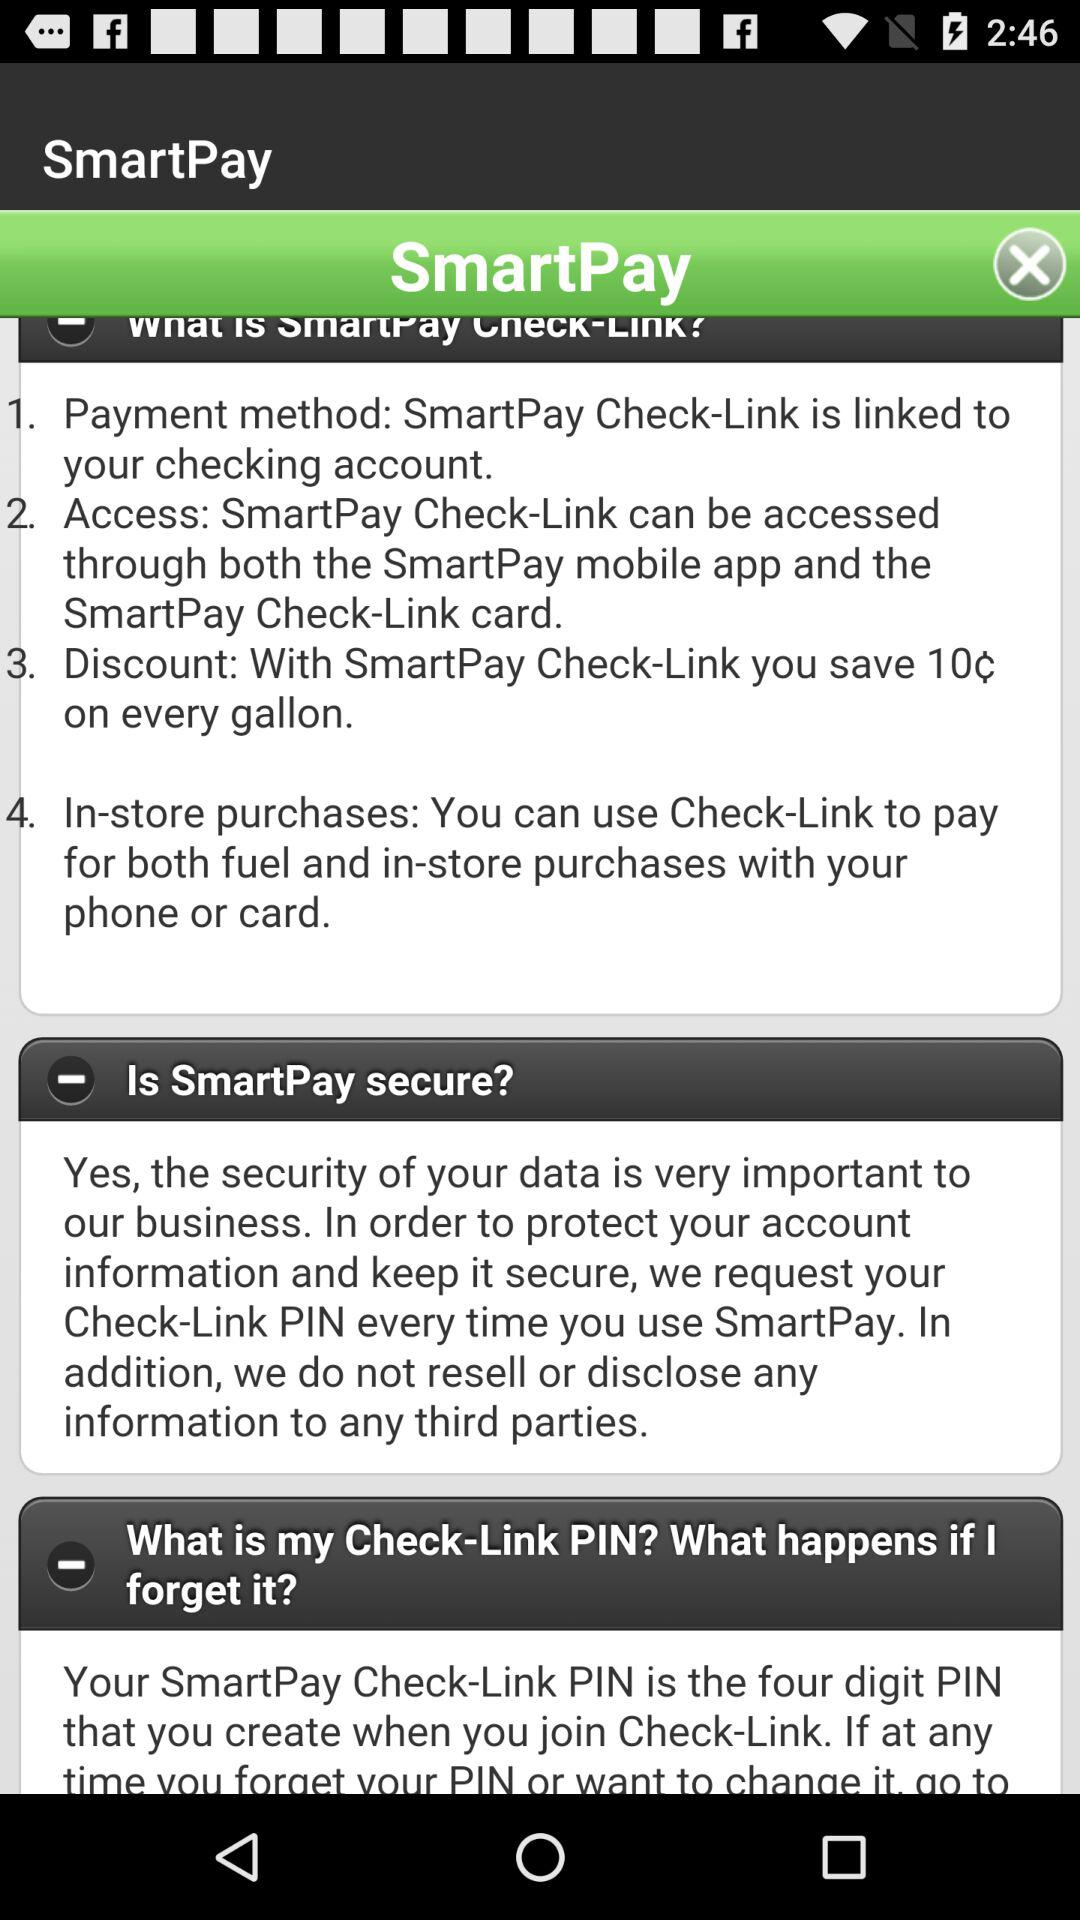What is the payment method? The payment method is "SmartPay Check-Link". 